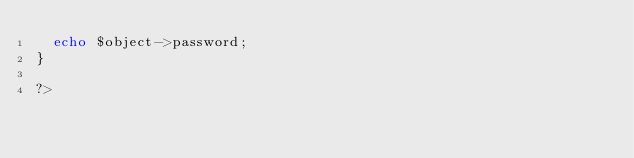<code> <loc_0><loc_0><loc_500><loc_500><_PHP_>	echo $object->password;
}

?></code> 